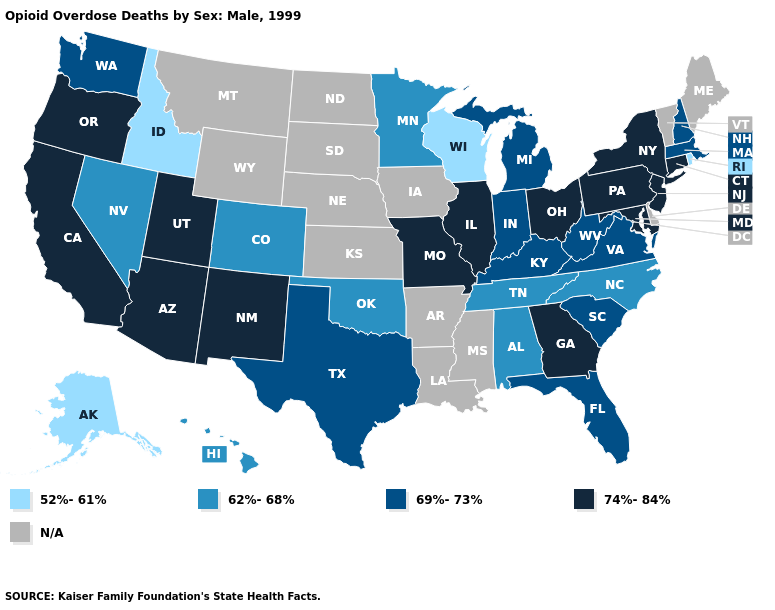What is the lowest value in the South?
Write a very short answer. 62%-68%. What is the value of North Dakota?
Quick response, please. N/A. Among the states that border Vermont , which have the lowest value?
Short answer required. Massachusetts, New Hampshire. What is the value of Georgia?
Short answer required. 74%-84%. What is the lowest value in the USA?
Write a very short answer. 52%-61%. What is the value of New Mexico?
Give a very brief answer. 74%-84%. Among the states that border Vermont , does New York have the lowest value?
Concise answer only. No. Name the states that have a value in the range 52%-61%?
Answer briefly. Alaska, Idaho, Rhode Island, Wisconsin. Name the states that have a value in the range 74%-84%?
Give a very brief answer. Arizona, California, Connecticut, Georgia, Illinois, Maryland, Missouri, New Jersey, New Mexico, New York, Ohio, Oregon, Pennsylvania, Utah. Is the legend a continuous bar?
Write a very short answer. No. Name the states that have a value in the range 52%-61%?
Short answer required. Alaska, Idaho, Rhode Island, Wisconsin. How many symbols are there in the legend?
Be succinct. 5. 